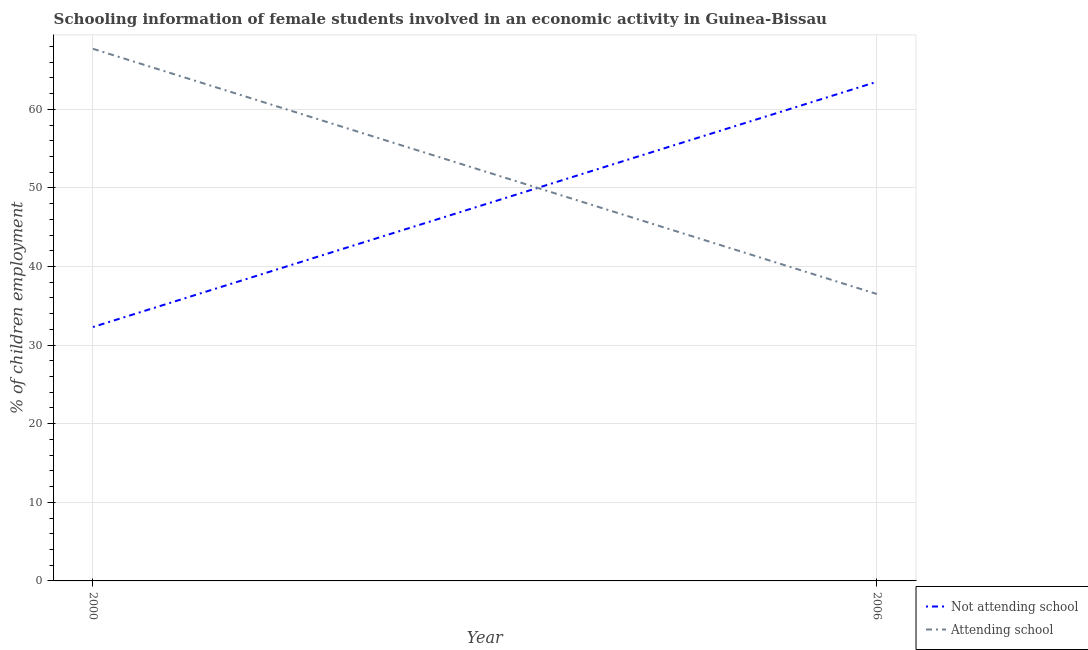What is the percentage of employed females who are not attending school in 2000?
Give a very brief answer. 32.3. Across all years, what is the maximum percentage of employed females who are not attending school?
Provide a short and direct response. 63.5. Across all years, what is the minimum percentage of employed females who are not attending school?
Ensure brevity in your answer.  32.3. In which year was the percentage of employed females who are attending school maximum?
Provide a succinct answer. 2000. In which year was the percentage of employed females who are attending school minimum?
Keep it short and to the point. 2006. What is the total percentage of employed females who are attending school in the graph?
Your answer should be compact. 104.2. What is the difference between the percentage of employed females who are not attending school in 2000 and that in 2006?
Your response must be concise. -31.2. What is the difference between the percentage of employed females who are attending school in 2006 and the percentage of employed females who are not attending school in 2000?
Offer a terse response. 4.2. What is the average percentage of employed females who are not attending school per year?
Your answer should be compact. 47.9. In the year 2006, what is the difference between the percentage of employed females who are not attending school and percentage of employed females who are attending school?
Provide a short and direct response. 27. What is the ratio of the percentage of employed females who are not attending school in 2000 to that in 2006?
Provide a succinct answer. 0.51. Is the percentage of employed females who are attending school in 2000 less than that in 2006?
Your answer should be very brief. No. In how many years, is the percentage of employed females who are not attending school greater than the average percentage of employed females who are not attending school taken over all years?
Provide a short and direct response. 1. Does the percentage of employed females who are not attending school monotonically increase over the years?
Your response must be concise. Yes. How many years are there in the graph?
Ensure brevity in your answer.  2. Does the graph contain any zero values?
Provide a short and direct response. No. Where does the legend appear in the graph?
Keep it short and to the point. Bottom right. What is the title of the graph?
Make the answer very short. Schooling information of female students involved in an economic activity in Guinea-Bissau. What is the label or title of the Y-axis?
Offer a very short reply. % of children employment. What is the % of children employment in Not attending school in 2000?
Offer a very short reply. 32.3. What is the % of children employment of Attending school in 2000?
Your answer should be very brief. 67.7. What is the % of children employment of Not attending school in 2006?
Provide a short and direct response. 63.5. What is the % of children employment of Attending school in 2006?
Offer a very short reply. 36.5. Across all years, what is the maximum % of children employment of Not attending school?
Your response must be concise. 63.5. Across all years, what is the maximum % of children employment of Attending school?
Provide a succinct answer. 67.7. Across all years, what is the minimum % of children employment in Not attending school?
Provide a short and direct response. 32.3. Across all years, what is the minimum % of children employment in Attending school?
Make the answer very short. 36.5. What is the total % of children employment in Not attending school in the graph?
Make the answer very short. 95.8. What is the total % of children employment of Attending school in the graph?
Provide a succinct answer. 104.2. What is the difference between the % of children employment of Not attending school in 2000 and that in 2006?
Offer a terse response. -31.2. What is the difference between the % of children employment of Attending school in 2000 and that in 2006?
Provide a short and direct response. 31.2. What is the difference between the % of children employment in Not attending school in 2000 and the % of children employment in Attending school in 2006?
Your answer should be compact. -4.2. What is the average % of children employment in Not attending school per year?
Your answer should be very brief. 47.9. What is the average % of children employment in Attending school per year?
Give a very brief answer. 52.1. In the year 2000, what is the difference between the % of children employment of Not attending school and % of children employment of Attending school?
Give a very brief answer. -35.4. What is the ratio of the % of children employment of Not attending school in 2000 to that in 2006?
Provide a short and direct response. 0.51. What is the ratio of the % of children employment of Attending school in 2000 to that in 2006?
Your answer should be very brief. 1.85. What is the difference between the highest and the second highest % of children employment of Not attending school?
Offer a terse response. 31.2. What is the difference between the highest and the second highest % of children employment in Attending school?
Provide a succinct answer. 31.2. What is the difference between the highest and the lowest % of children employment in Not attending school?
Provide a short and direct response. 31.2. What is the difference between the highest and the lowest % of children employment in Attending school?
Your response must be concise. 31.2. 